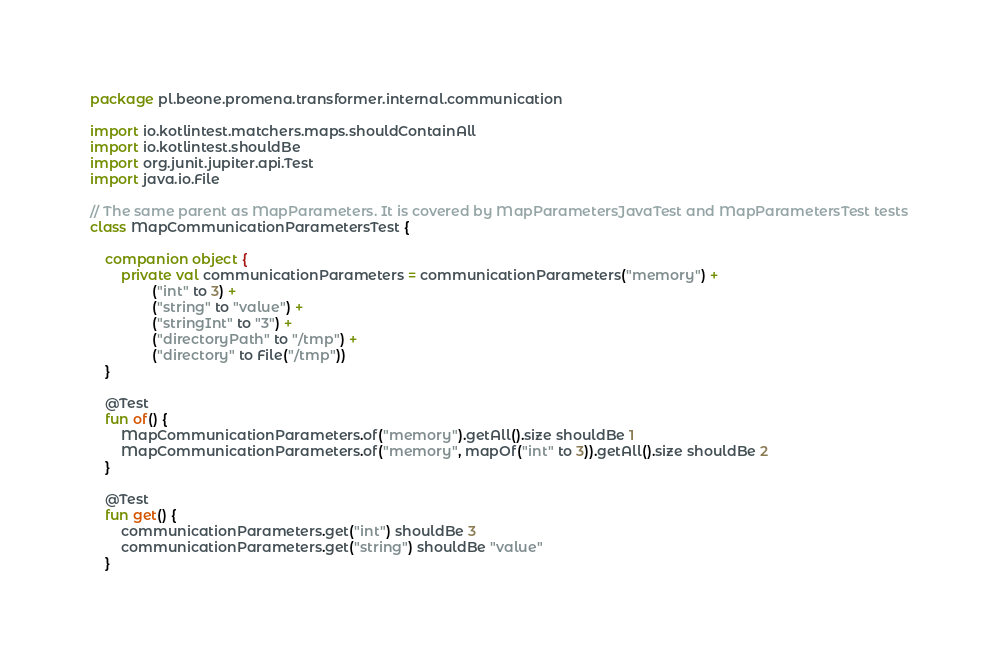<code> <loc_0><loc_0><loc_500><loc_500><_Kotlin_>package pl.beone.promena.transformer.internal.communication

import io.kotlintest.matchers.maps.shouldContainAll
import io.kotlintest.shouldBe
import org.junit.jupiter.api.Test
import java.io.File

// The same parent as MapParameters. It is covered by MapParametersJavaTest and MapParametersTest tests
class MapCommunicationParametersTest {

    companion object {
        private val communicationParameters = communicationParameters("memory") +
                ("int" to 3) +
                ("string" to "value") +
                ("stringInt" to "3") +
                ("directoryPath" to "/tmp") +
                ("directory" to File("/tmp"))
    }

    @Test
    fun of() {
        MapCommunicationParameters.of("memory").getAll().size shouldBe 1
        MapCommunicationParameters.of("memory", mapOf("int" to 3)).getAll().size shouldBe 2
    }

    @Test
    fun get() {
        communicationParameters.get("int") shouldBe 3
        communicationParameters.get("string") shouldBe "value"
    }
</code> 